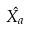Convert formula to latex. <formula><loc_0><loc_0><loc_500><loc_500>\hat { X _ { a } }</formula> 